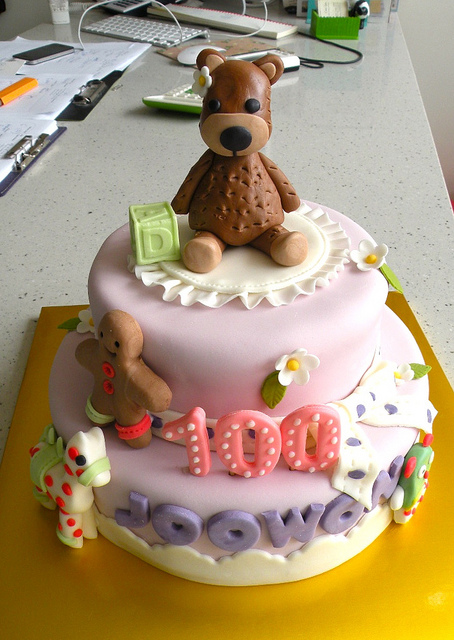Please identify all text content in this image. JOOWON 100 D 